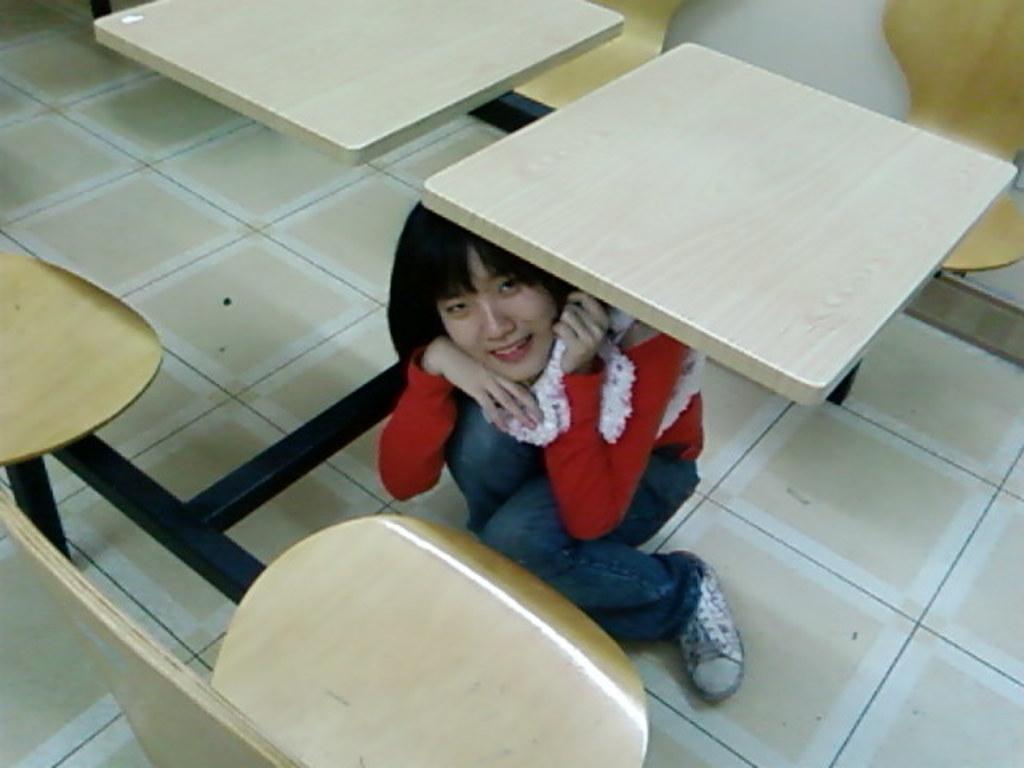In one or two sentences, can you explain what this image depicts? In this picture we can see a girl wearing a red t-shirt and blue jeans, sitting under the wooden bench. Above we can see the bench and yellow chairs. 